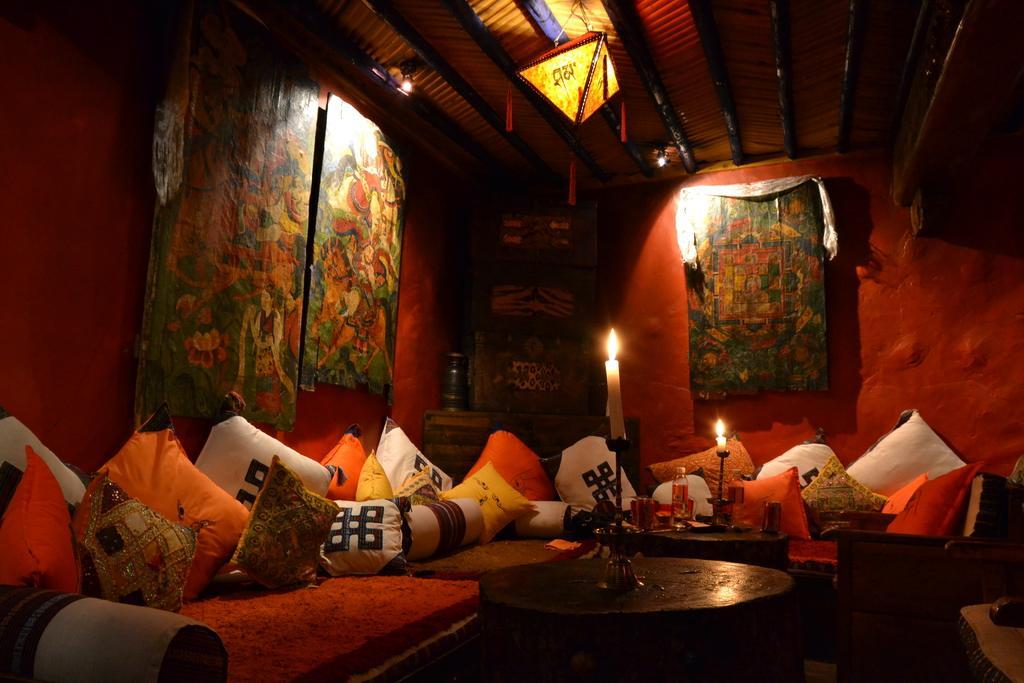Can you describe this image briefly? In this image, I can see candles on the candle stand, water bottle and few other things placed on the tables. I can see the couches with cushions on it. It looks like a wooden object, which is behind a couch. I can see the photo frames, which are attached to the walls. At the top of the image, this is a lantern hanging to the ceiling. 